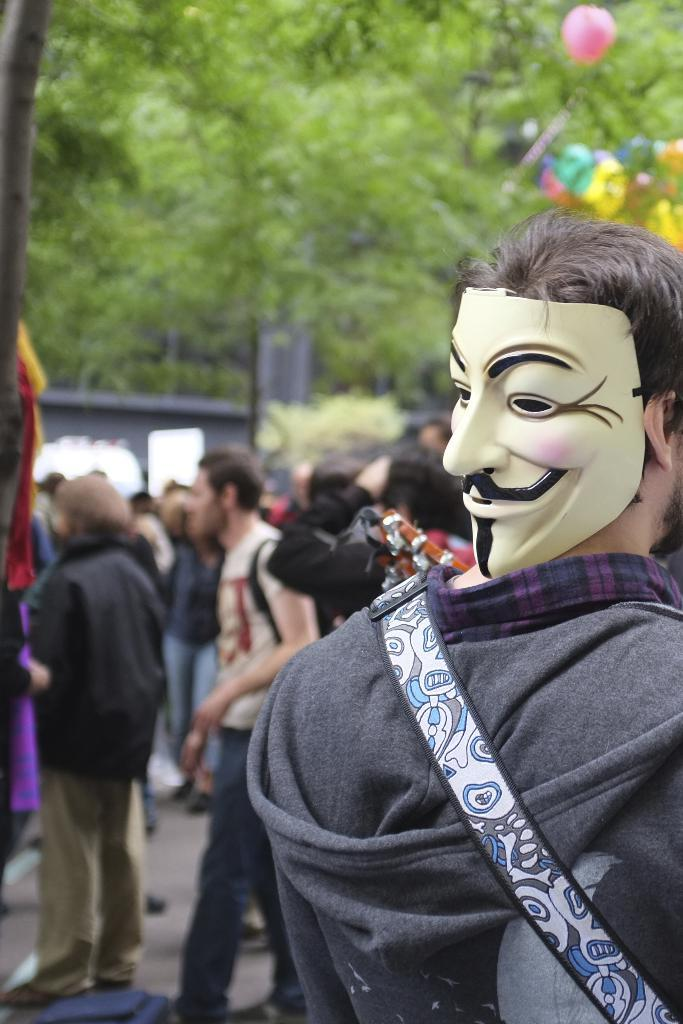How many people are in the image? There is a group of people in the image. What is the position of the people in the image? The people are standing on the ground. Can you describe the appearance of the person in the front? The person in the front is wearing a mask. What can be seen in the background of the image? There is a balloon visible in the background of the image, along with other objects. How long did the journey take for the people in the image? There is no information about a journey in the image, as the people are simply standing on the ground. 